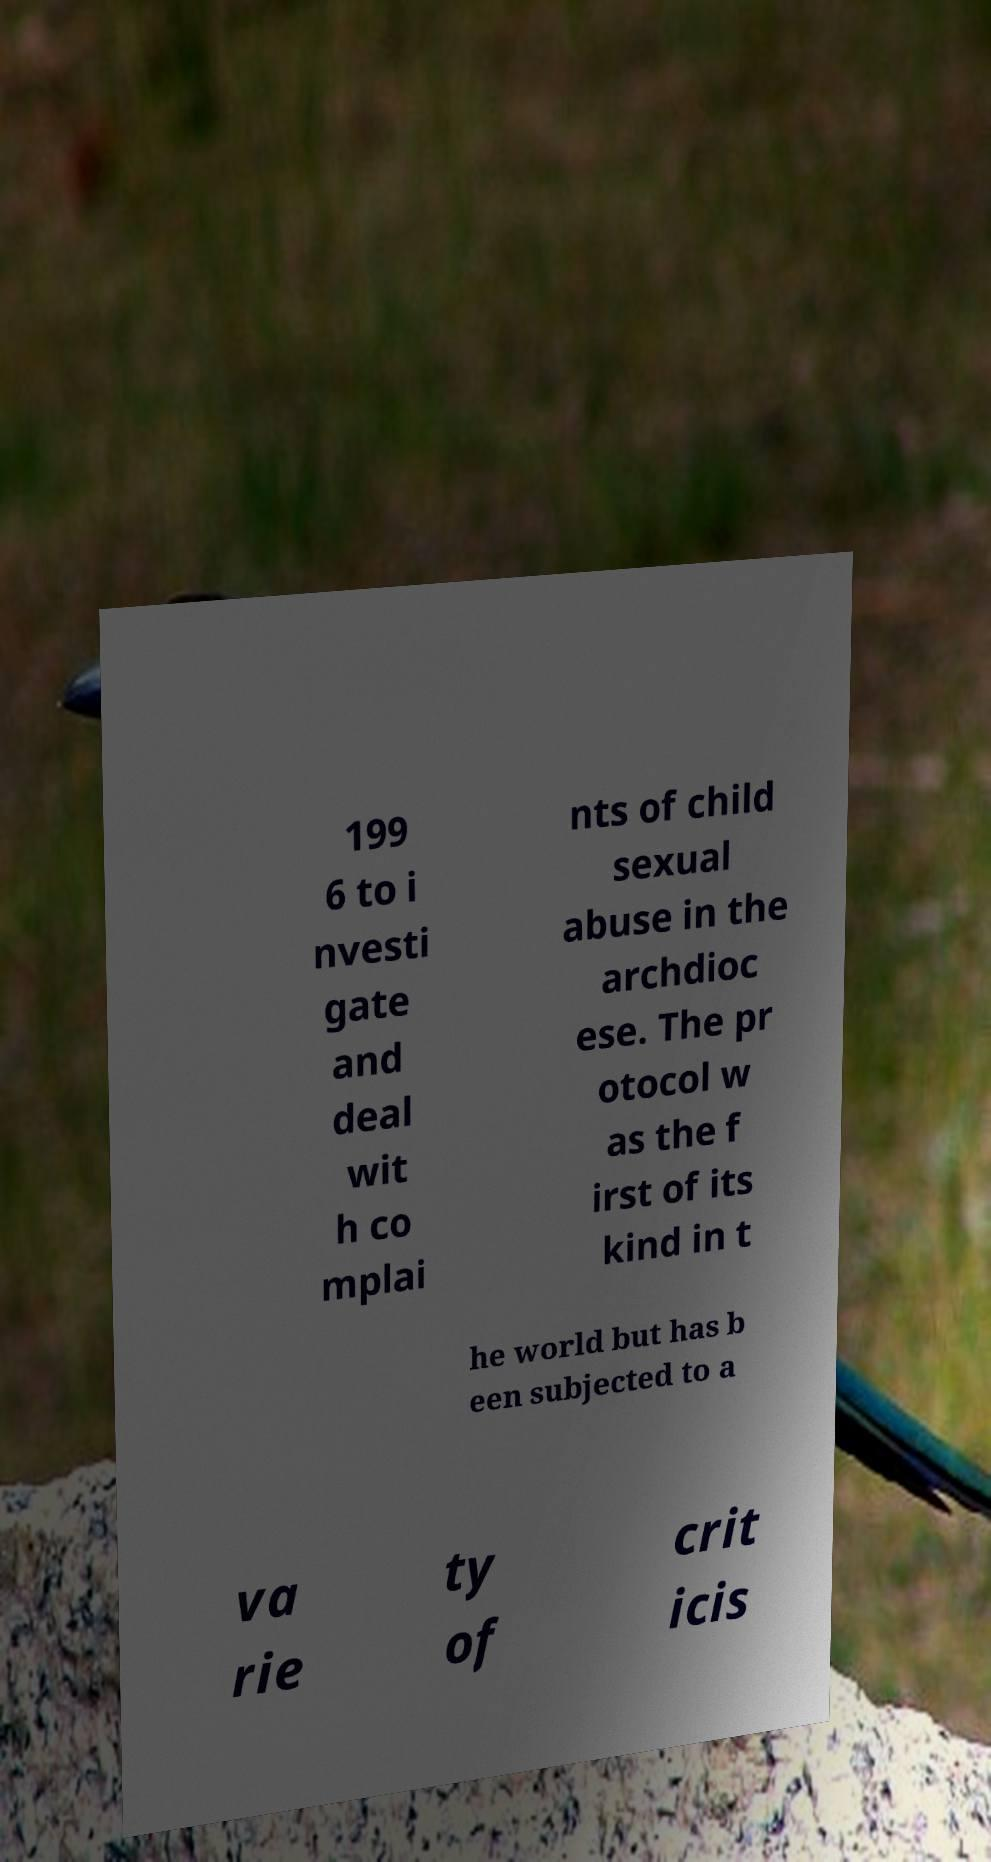I need the written content from this picture converted into text. Can you do that? 199 6 to i nvesti gate and deal wit h co mplai nts of child sexual abuse in the archdioc ese. The pr otocol w as the f irst of its kind in t he world but has b een subjected to a va rie ty of crit icis 